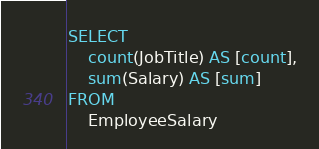Convert code to text. <code><loc_0><loc_0><loc_500><loc_500><_SQL_>SELECT
    count(JobTitle) AS [count],
    sum(Salary) AS [sum]
FROM
    EmployeeSalary</code> 